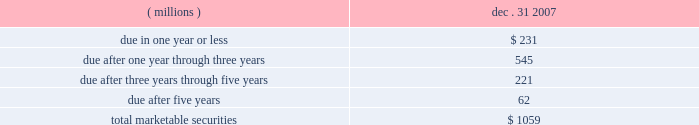28 , 35 , or 90 days .
The funds associated with failed auctions will not be accessible until a successful auction occurs or a buyer is found outside of the auction process .
Based on broker- dealer valuation models and an analysis of other-than-temporary impairment factors , auction rate securities with an original par value of approximately $ 34 million were written-down to an estimated fair value of $ 16 million as of december 31 , 2007 .
This write-down resulted in an 201cother-than-temporary 201d impairment charge of approximately $ 8 million ( pre-tax ) included in net income and a temporary impairment charge of $ 10 million ( pre-tax ) reflected as an unrealized loss within other comprehensive income for 2007 .
As of december 31 , 2007 , these investments in auction rate securities have been in a loss position for less than six months .
These auction rate securities are classified as non-current marketable securities as of december 31 , 2007 as indicated in the preceding table .
3m reviews impairments associated with the above in accordance with emerging issues task force ( eitf ) 03-1 and fsp sfas 115-1 and 124-1 , 201cthe meaning of other-than-temporary-impairment and its application to certain investments , 201d to determine the classification of the impairment as 201ctemporary 201d or 201cother-than-temporary . 201d a temporary impairment charge results in an unrealized loss being recorded in the other comprehensive income component of stockholders 2019 equity .
Such an unrealized loss does not reduce net income for the applicable accounting period because the loss is not viewed as other-than-temporary .
The company believes that a portion of the impairment of its auction rate securities investments is temporary and a portion is other-than-temporary .
The factors evaluated to differentiate between temporary and other-than-temporary include the projected future cash flows , credit ratings actions , and assessment of the credit quality of the underlying collateral .
The balance at december 31 , 2007 for marketable securities and short-term investments by contractual maturity are shown below .
Actual maturities may differ from contractual maturities because the issuers of the securities may have the right to prepay obligations without prepayment penalties .
Dec .
31 , ( millions ) 2007 .
Predetermined intervals , usually every 7 .
What was the rate of the adjustment of the auction rate securities with an original par value of approximately $ 34 million were written-down to an estimated fair value of $ 16 million as of december 31 , 2007.\\n? 
Computations: ((34 - 16) / 34)
Answer: 0.52941. 